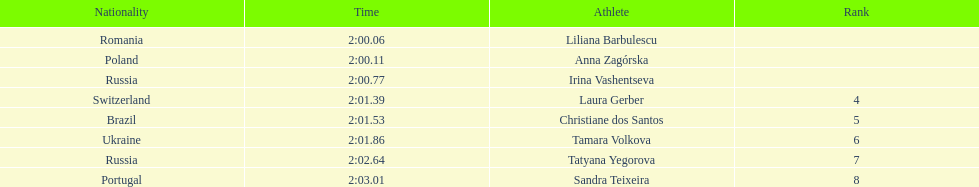Anna zagorska recieved 2nd place, what was her time? 2:00.11. 